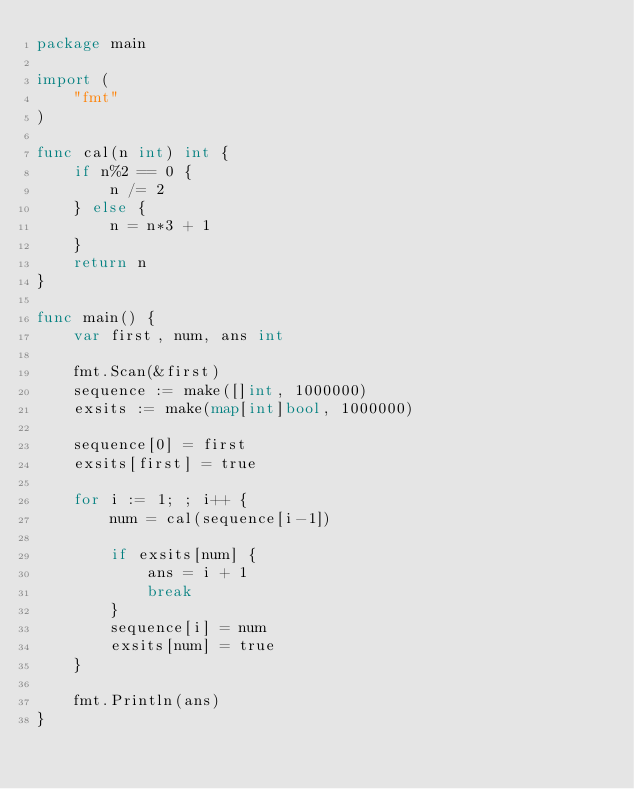Convert code to text. <code><loc_0><loc_0><loc_500><loc_500><_Go_>package main

import (
	"fmt"
)

func cal(n int) int {
	if n%2 == 0 {
		n /= 2
	} else {
		n = n*3 + 1
	}
	return n
}

func main() {
	var first, num, ans int

	fmt.Scan(&first)
	sequence := make([]int, 1000000)
	exsits := make(map[int]bool, 1000000)

	sequence[0] = first
	exsits[first] = true

	for i := 1; ; i++ {
		num = cal(sequence[i-1])

		if exsits[num] {
			ans = i + 1
			break
		}
		sequence[i] = num
		exsits[num] = true
	}

	fmt.Println(ans)
}
</code> 